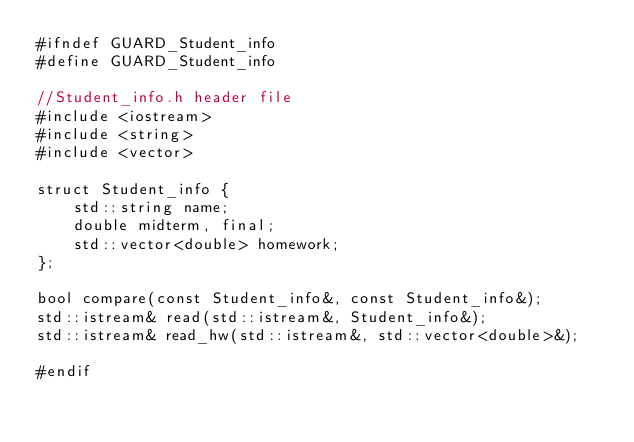Convert code to text. <code><loc_0><loc_0><loc_500><loc_500><_C_>#ifndef GUARD_Student_info
#define GUARD_Student_info

//Student_info.h header file
#include <iostream>
#include <string>
#include <vector>

struct Student_info {
    std::string name;
    double midterm, final;
    std::vector<double> homework;
};

bool compare(const Student_info&, const Student_info&);
std::istream& read(std::istream&, Student_info&);
std::istream& read_hw(std::istream&, std::vector<double>&);

#endif
</code> 